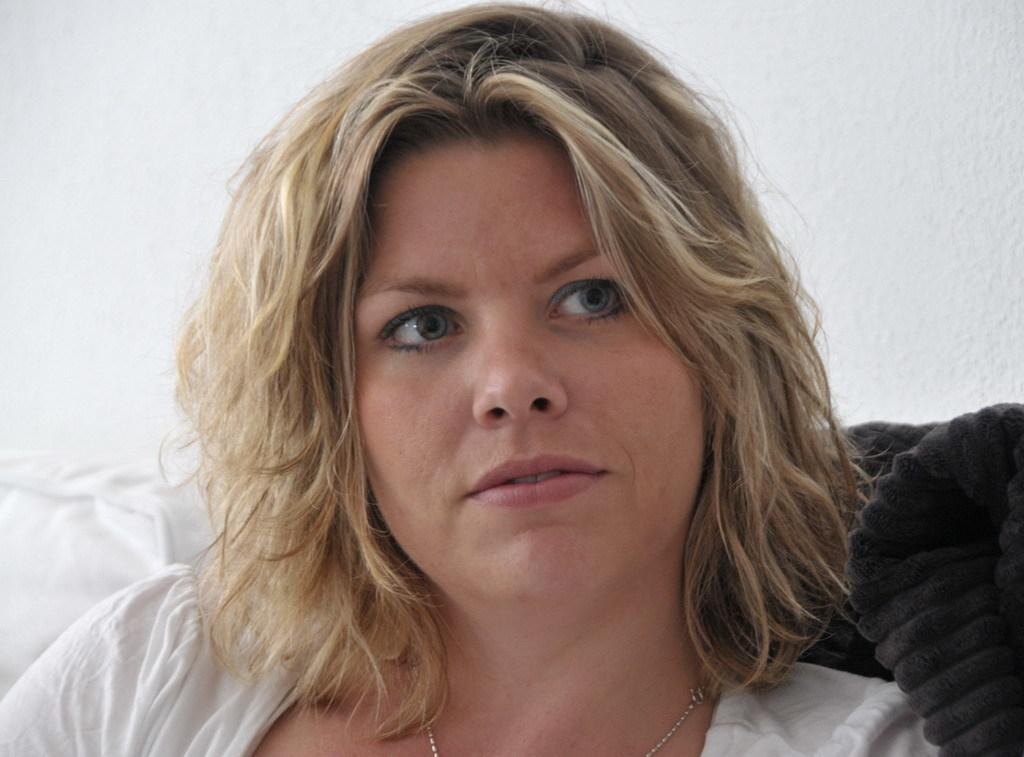What is the main subject in the image? There is a person in the image. Can you describe any other objects or elements in the image? There is an object in the image. What color is the background of the image? The background of the image is white. How many feet does the person have in the image? The number of feet the person has cannot be determined from the image, as it only shows a person and an object with a white background. 